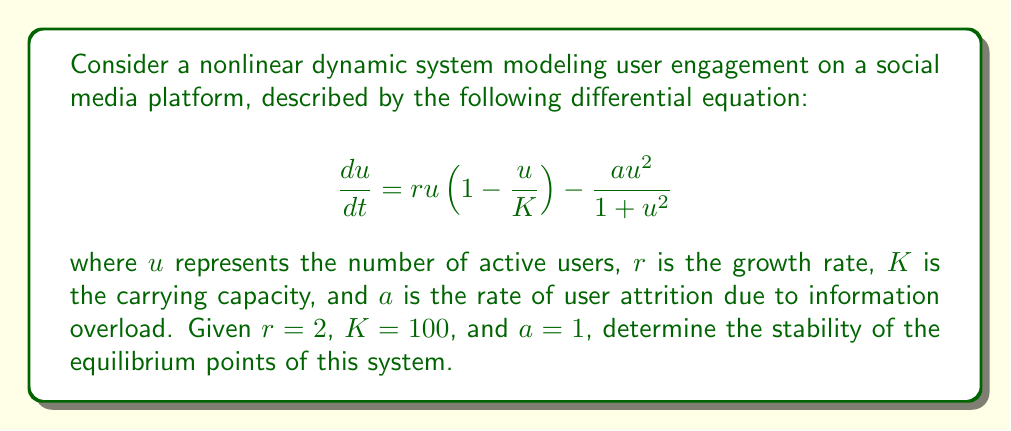Can you answer this question? To determine the stability of the equilibrium points, we follow these steps:

1) Find the equilibrium points by setting $\frac{du}{dt} = 0$:

   $$0 = ru(1-\frac{u}{K}) - \frac{au^2}{1+u^2}$$

2) Substitute the given values:

   $$0 = 2u(1-\frac{u}{100}) - \frac{u^2}{1+u^2}$$

3) Simplify:

   $$0 = 2u - \frac{2u^2}{100} - \frac{u^2}{1+u^2}$$

4) Multiply both sides by $(1+u^2)$:

   $$0 = 2u(1+u^2) - \frac{2u^2(1+u^2)}{100} - u^2$$

5) Expand and collect terms:

   $$0 = 2u + 2u^3 - \frac{2u^2}{100} - \frac{2u^4}{100} - u^2$$

6) This equation has three roots: $u=0$, and two non-zero roots. We can find the non-zero roots numerically: $u \approx 33.2$ and $u \approx 95.4$.

7) To determine stability, we need to find the derivative of $\frac{du}{dt}$ with respect to $u$ and evaluate it at each equilibrium point:

   $$\frac{d}{du}(\frac{du}{dt}) = r(1-\frac{2u}{K}) - \frac{a(2u-2u^3)}{(1+u^2)^2}$$

8) Substitute the given values:

   $$\frac{d}{du}(\frac{du}{dt}) = 2(1-\frac{2u}{100}) - \frac{2u-2u^3}{(1+u^2)^2}$$

9) Evaluate this at each equilibrium point:
   
   At $u=0$: $\frac{d}{du}(\frac{du}{dt}) = 2 > 0$, unstable.
   
   At $u \approx 33.2$: $\frac{d}{du}(\frac{du}{dt}) \approx -0.12 < 0$, stable.
   
   At $u \approx 95.4$: $\frac{d}{du}(\frac{du}{dt}) \approx 0.04 > 0$, unstable.

Therefore, the system has one stable equilibrium point at $u \approx 33.2$, and two unstable equilibrium points at $u=0$ and $u \approx 95.4$.
Answer: One stable equilibrium at $u \approx 33.2$, two unstable equilibria at $u=0$ and $u \approx 95.4$. 